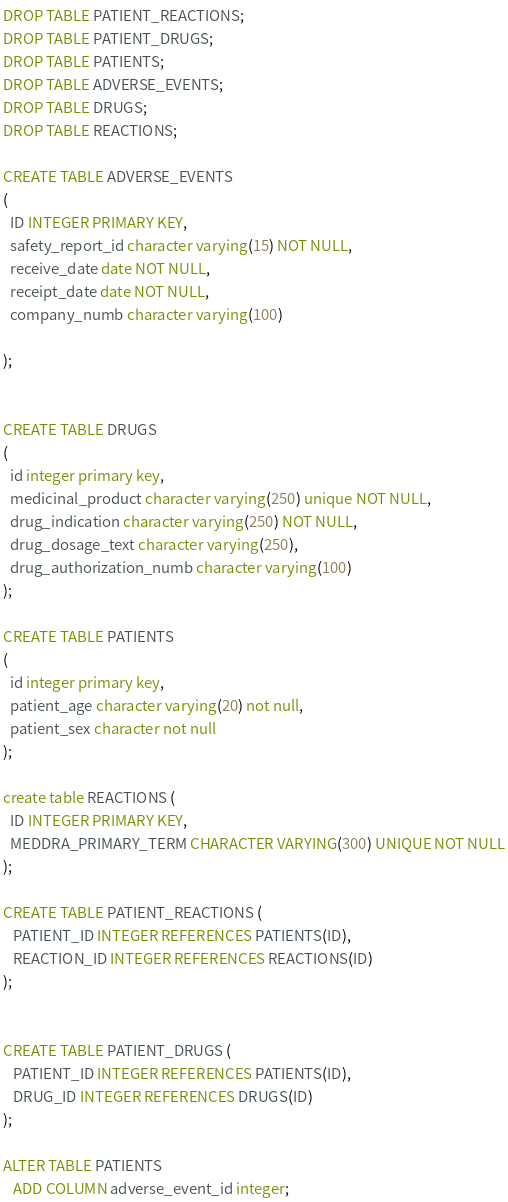Convert code to text. <code><loc_0><loc_0><loc_500><loc_500><_SQL_>DROP TABLE PATIENT_REACTIONS;
DROP TABLE PATIENT_DRUGS;
DROP TABLE PATIENTS;
DROP TABLE ADVERSE_EVENTS;
DROP TABLE DRUGS;
DROP TABLE REACTIONS;

CREATE TABLE ADVERSE_EVENTS
(
  ID INTEGER PRIMARY KEY,
  safety_report_id character varying(15) NOT NULL,
  receive_date date NOT NULL,
  receipt_date date NOT NULL,
  company_numb character varying(100)

);


CREATE TABLE DRUGS
(
  id integer primary key,
  medicinal_product character varying(250) unique NOT NULL,
  drug_indication character varying(250) NOT NULL,
  drug_dosage_text character varying(250),
  drug_authorization_numb character varying(100)
);

CREATE TABLE PATIENTS
(
  id integer primary key,
  patient_age character varying(20) not null,
  patient_sex character not null
);

create table REACTIONS (
  ID INTEGER PRIMARY KEY,
  MEDDRA_PRIMARY_TERM CHARACTER VARYING(300) UNIQUE NOT NULL
);

CREATE TABLE PATIENT_REACTIONS (
   PATIENT_ID INTEGER REFERENCES PATIENTS(ID),
   REACTION_ID INTEGER REFERENCES REACTIONS(ID)
);


CREATE TABLE PATIENT_DRUGS (
   PATIENT_ID INTEGER REFERENCES PATIENTS(ID),
   DRUG_ID INTEGER REFERENCES DRUGS(ID)
);

ALTER TABLE PATIENTS
   ADD COLUMN adverse_event_id integer;
</code> 